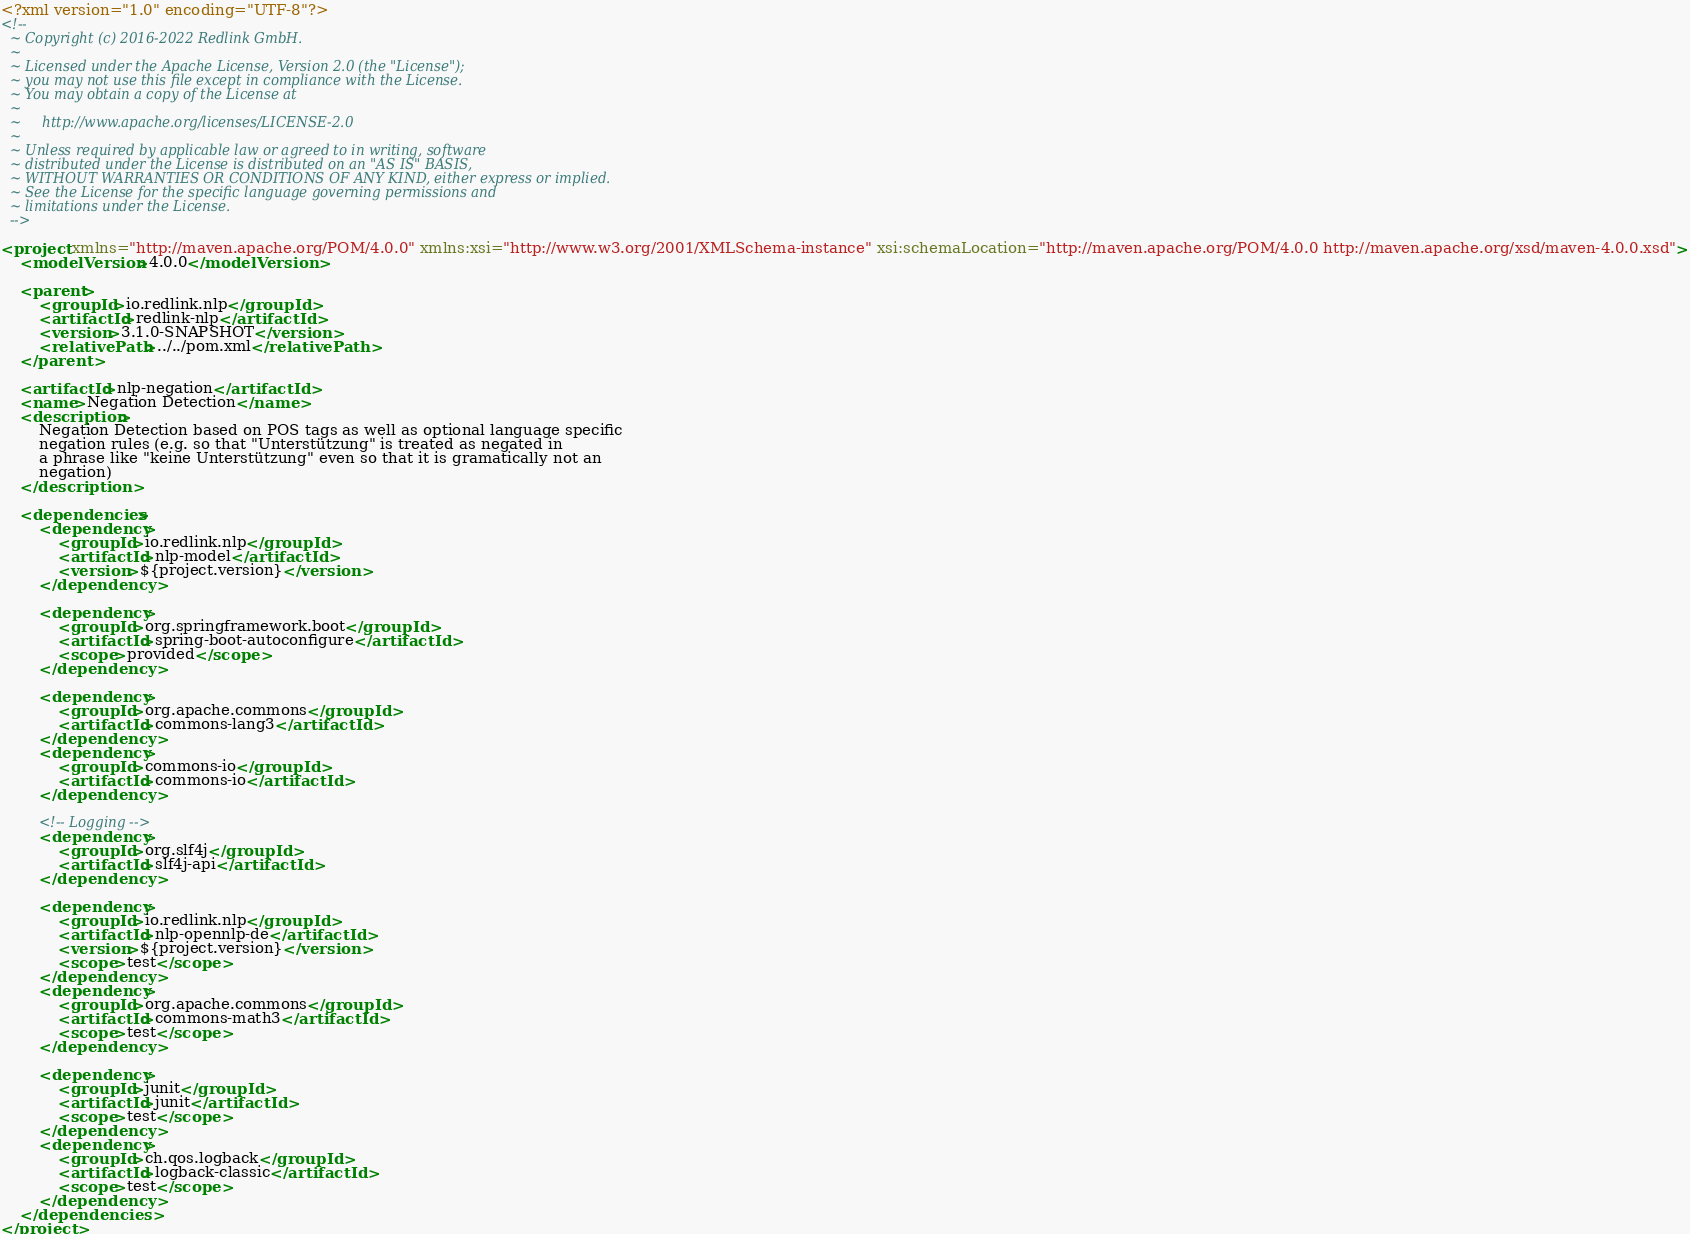Convert code to text. <code><loc_0><loc_0><loc_500><loc_500><_XML_><?xml version="1.0" encoding="UTF-8"?>
<!--
  ~ Copyright (c) 2016-2022 Redlink GmbH.
  ~
  ~ Licensed under the Apache License, Version 2.0 (the "License");
  ~ you may not use this file except in compliance with the License.
  ~ You may obtain a copy of the License at
  ~
  ~     http://www.apache.org/licenses/LICENSE-2.0
  ~
  ~ Unless required by applicable law or agreed to in writing, software
  ~ distributed under the License is distributed on an "AS IS" BASIS,
  ~ WITHOUT WARRANTIES OR CONDITIONS OF ANY KIND, either express or implied.
  ~ See the License for the specific language governing permissions and
  ~ limitations under the License.
  -->

<project xmlns="http://maven.apache.org/POM/4.0.0" xmlns:xsi="http://www.w3.org/2001/XMLSchema-instance" xsi:schemaLocation="http://maven.apache.org/POM/4.0.0 http://maven.apache.org/xsd/maven-4.0.0.xsd">
    <modelVersion>4.0.0</modelVersion>

    <parent>
        <groupId>io.redlink.nlp</groupId>
        <artifactId>redlink-nlp</artifactId>
        <version>3.1.0-SNAPSHOT</version>
        <relativePath>../../pom.xml</relativePath>
    </parent>

    <artifactId>nlp-negation</artifactId>
    <name>Negation Detection</name>
    <description>
        Negation Detection based on POS tags as well as optional language specific
        negation rules (e.g. so that "Unterstützung" is treated as negated in
        a phrase like "keine Unterstützung" even so that it is gramatically not an
        negation)
    </description>

    <dependencies>
        <dependency>
            <groupId>io.redlink.nlp</groupId>
            <artifactId>nlp-model</artifactId>
            <version>${project.version}</version>
        </dependency>

        <dependency>
            <groupId>org.springframework.boot</groupId>
            <artifactId>spring-boot-autoconfigure</artifactId>
            <scope>provided</scope>
        </dependency>

        <dependency>
            <groupId>org.apache.commons</groupId>
            <artifactId>commons-lang3</artifactId>
        </dependency>
        <dependency>
            <groupId>commons-io</groupId>
            <artifactId>commons-io</artifactId>
        </dependency>

        <!-- Logging -->
        <dependency>
            <groupId>org.slf4j</groupId>
            <artifactId>slf4j-api</artifactId>
        </dependency>

        <dependency>
            <groupId>io.redlink.nlp</groupId>
            <artifactId>nlp-opennlp-de</artifactId>
            <version>${project.version}</version>
            <scope>test</scope>
        </dependency>
        <dependency>
            <groupId>org.apache.commons</groupId>
            <artifactId>commons-math3</artifactId>
            <scope>test</scope>
        </dependency>

        <dependency>
            <groupId>junit</groupId>
            <artifactId>junit</artifactId>
            <scope>test</scope>
        </dependency>
        <dependency>
            <groupId>ch.qos.logback</groupId>
            <artifactId>logback-classic</artifactId>
            <scope>test</scope>
        </dependency>
    </dependencies>
</project></code> 